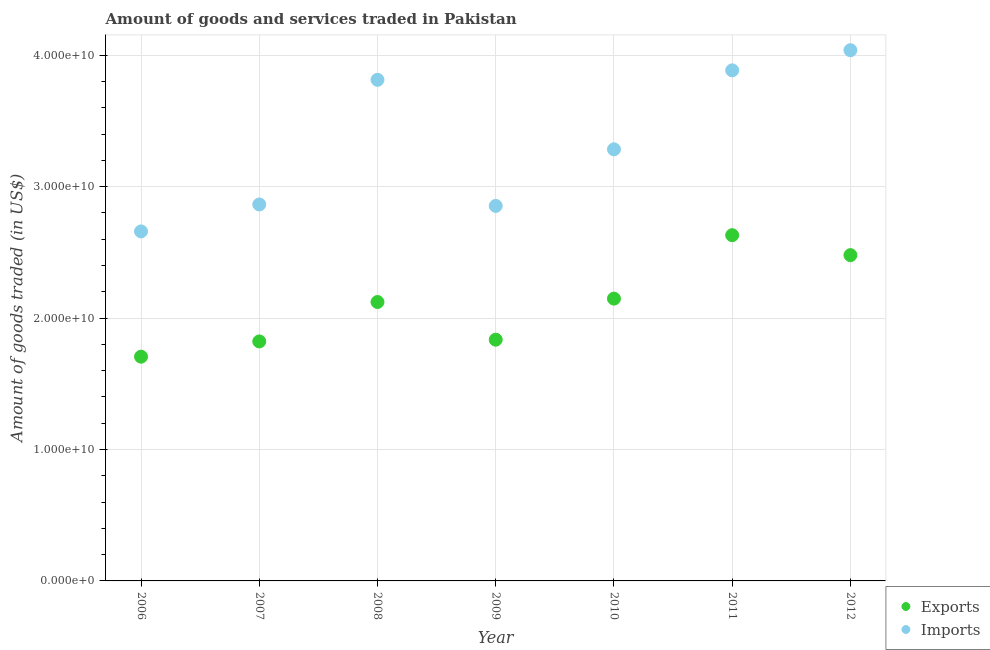How many different coloured dotlines are there?
Make the answer very short. 2. What is the amount of goods exported in 2006?
Provide a succinct answer. 1.71e+1. Across all years, what is the maximum amount of goods imported?
Provide a succinct answer. 4.04e+1. Across all years, what is the minimum amount of goods imported?
Your answer should be very brief. 2.66e+1. In which year was the amount of goods exported maximum?
Provide a short and direct response. 2011. What is the total amount of goods imported in the graph?
Your response must be concise. 2.34e+11. What is the difference between the amount of goods imported in 2006 and that in 2010?
Provide a succinct answer. -6.24e+09. What is the difference between the amount of goods exported in 2010 and the amount of goods imported in 2012?
Offer a terse response. -1.89e+1. What is the average amount of goods exported per year?
Keep it short and to the point. 2.11e+1. In the year 2006, what is the difference between the amount of goods exported and amount of goods imported?
Give a very brief answer. -9.53e+09. In how many years, is the amount of goods exported greater than 6000000000 US$?
Provide a short and direct response. 7. What is the ratio of the amount of goods exported in 2007 to that in 2010?
Provide a succinct answer. 0.85. Is the amount of goods imported in 2010 less than that in 2012?
Provide a short and direct response. Yes. What is the difference between the highest and the second highest amount of goods exported?
Offer a very short reply. 1.52e+09. What is the difference between the highest and the lowest amount of goods imported?
Give a very brief answer. 1.38e+1. Is the sum of the amount of goods imported in 2007 and 2009 greater than the maximum amount of goods exported across all years?
Offer a terse response. Yes. Does the amount of goods exported monotonically increase over the years?
Provide a succinct answer. No. What is the difference between two consecutive major ticks on the Y-axis?
Ensure brevity in your answer.  1.00e+1. Does the graph contain any zero values?
Offer a terse response. No. Does the graph contain grids?
Provide a short and direct response. Yes. Where does the legend appear in the graph?
Offer a very short reply. Bottom right. How are the legend labels stacked?
Give a very brief answer. Vertical. What is the title of the graph?
Keep it short and to the point. Amount of goods and services traded in Pakistan. What is the label or title of the Y-axis?
Your answer should be compact. Amount of goods traded (in US$). What is the Amount of goods traded (in US$) of Exports in 2006?
Your response must be concise. 1.71e+1. What is the Amount of goods traded (in US$) in Imports in 2006?
Provide a short and direct response. 2.66e+1. What is the Amount of goods traded (in US$) of Exports in 2007?
Keep it short and to the point. 1.82e+1. What is the Amount of goods traded (in US$) in Imports in 2007?
Offer a very short reply. 2.86e+1. What is the Amount of goods traded (in US$) of Exports in 2008?
Provide a short and direct response. 2.12e+1. What is the Amount of goods traded (in US$) in Imports in 2008?
Ensure brevity in your answer.  3.81e+1. What is the Amount of goods traded (in US$) in Exports in 2009?
Provide a succinct answer. 1.84e+1. What is the Amount of goods traded (in US$) of Imports in 2009?
Your response must be concise. 2.85e+1. What is the Amount of goods traded (in US$) of Exports in 2010?
Your answer should be very brief. 2.15e+1. What is the Amount of goods traded (in US$) of Imports in 2010?
Your answer should be very brief. 3.28e+1. What is the Amount of goods traded (in US$) in Exports in 2011?
Your answer should be compact. 2.63e+1. What is the Amount of goods traded (in US$) of Imports in 2011?
Your answer should be very brief. 3.89e+1. What is the Amount of goods traded (in US$) in Exports in 2012?
Offer a terse response. 2.48e+1. What is the Amount of goods traded (in US$) in Imports in 2012?
Give a very brief answer. 4.04e+1. Across all years, what is the maximum Amount of goods traded (in US$) of Exports?
Your answer should be compact. 2.63e+1. Across all years, what is the maximum Amount of goods traded (in US$) in Imports?
Your response must be concise. 4.04e+1. Across all years, what is the minimum Amount of goods traded (in US$) of Exports?
Ensure brevity in your answer.  1.71e+1. Across all years, what is the minimum Amount of goods traded (in US$) of Imports?
Provide a short and direct response. 2.66e+1. What is the total Amount of goods traded (in US$) in Exports in the graph?
Your answer should be very brief. 1.47e+11. What is the total Amount of goods traded (in US$) in Imports in the graph?
Your response must be concise. 2.34e+11. What is the difference between the Amount of goods traded (in US$) of Exports in 2006 and that in 2007?
Your answer should be very brief. -1.16e+09. What is the difference between the Amount of goods traded (in US$) in Imports in 2006 and that in 2007?
Provide a succinct answer. -2.05e+09. What is the difference between the Amount of goods traded (in US$) in Exports in 2006 and that in 2008?
Make the answer very short. -4.16e+09. What is the difference between the Amount of goods traded (in US$) of Imports in 2006 and that in 2008?
Your answer should be very brief. -1.15e+1. What is the difference between the Amount of goods traded (in US$) of Exports in 2006 and that in 2009?
Your answer should be very brief. -1.29e+09. What is the difference between the Amount of goods traded (in US$) of Imports in 2006 and that in 2009?
Keep it short and to the point. -1.94e+09. What is the difference between the Amount of goods traded (in US$) in Exports in 2006 and that in 2010?
Keep it short and to the point. -4.42e+09. What is the difference between the Amount of goods traded (in US$) in Imports in 2006 and that in 2010?
Your response must be concise. -6.24e+09. What is the difference between the Amount of goods traded (in US$) in Exports in 2006 and that in 2011?
Give a very brief answer. -9.24e+09. What is the difference between the Amount of goods traded (in US$) of Imports in 2006 and that in 2011?
Give a very brief answer. -1.23e+1. What is the difference between the Amount of goods traded (in US$) in Exports in 2006 and that in 2012?
Your answer should be compact. -7.73e+09. What is the difference between the Amount of goods traded (in US$) of Imports in 2006 and that in 2012?
Ensure brevity in your answer.  -1.38e+1. What is the difference between the Amount of goods traded (in US$) in Exports in 2007 and that in 2008?
Provide a short and direct response. -3.00e+09. What is the difference between the Amount of goods traded (in US$) in Imports in 2007 and that in 2008?
Ensure brevity in your answer.  -9.49e+09. What is the difference between the Amount of goods traded (in US$) in Exports in 2007 and that in 2009?
Your response must be concise. -1.33e+08. What is the difference between the Amount of goods traded (in US$) in Imports in 2007 and that in 2009?
Offer a terse response. 1.10e+08. What is the difference between the Amount of goods traded (in US$) in Exports in 2007 and that in 2010?
Your answer should be very brief. -3.26e+09. What is the difference between the Amount of goods traded (in US$) of Imports in 2007 and that in 2010?
Provide a succinct answer. -4.20e+09. What is the difference between the Amount of goods traded (in US$) of Exports in 2007 and that in 2011?
Make the answer very short. -8.08e+09. What is the difference between the Amount of goods traded (in US$) in Imports in 2007 and that in 2011?
Your answer should be very brief. -1.02e+1. What is the difference between the Amount of goods traded (in US$) of Exports in 2007 and that in 2012?
Your answer should be very brief. -6.57e+09. What is the difference between the Amount of goods traded (in US$) of Imports in 2007 and that in 2012?
Your answer should be compact. -1.17e+1. What is the difference between the Amount of goods traded (in US$) of Exports in 2008 and that in 2009?
Offer a terse response. 2.87e+09. What is the difference between the Amount of goods traded (in US$) in Imports in 2008 and that in 2009?
Ensure brevity in your answer.  9.60e+09. What is the difference between the Amount of goods traded (in US$) of Exports in 2008 and that in 2010?
Ensure brevity in your answer.  -2.58e+08. What is the difference between the Amount of goods traded (in US$) in Imports in 2008 and that in 2010?
Your answer should be very brief. 5.29e+09. What is the difference between the Amount of goods traded (in US$) of Exports in 2008 and that in 2011?
Keep it short and to the point. -5.08e+09. What is the difference between the Amount of goods traded (in US$) of Imports in 2008 and that in 2011?
Your response must be concise. -7.20e+08. What is the difference between the Amount of goods traded (in US$) of Exports in 2008 and that in 2012?
Give a very brief answer. -3.57e+09. What is the difference between the Amount of goods traded (in US$) in Imports in 2008 and that in 2012?
Keep it short and to the point. -2.25e+09. What is the difference between the Amount of goods traded (in US$) of Exports in 2009 and that in 2010?
Offer a terse response. -3.12e+09. What is the difference between the Amount of goods traded (in US$) in Imports in 2009 and that in 2010?
Keep it short and to the point. -4.31e+09. What is the difference between the Amount of goods traded (in US$) of Exports in 2009 and that in 2011?
Ensure brevity in your answer.  -7.95e+09. What is the difference between the Amount of goods traded (in US$) in Imports in 2009 and that in 2011?
Offer a terse response. -1.03e+1. What is the difference between the Amount of goods traded (in US$) in Exports in 2009 and that in 2012?
Provide a short and direct response. -6.43e+09. What is the difference between the Amount of goods traded (in US$) in Imports in 2009 and that in 2012?
Keep it short and to the point. -1.18e+1. What is the difference between the Amount of goods traded (in US$) in Exports in 2010 and that in 2011?
Provide a short and direct response. -4.83e+09. What is the difference between the Amount of goods traded (in US$) of Imports in 2010 and that in 2011?
Ensure brevity in your answer.  -6.01e+09. What is the difference between the Amount of goods traded (in US$) of Exports in 2010 and that in 2012?
Your answer should be compact. -3.31e+09. What is the difference between the Amount of goods traded (in US$) of Imports in 2010 and that in 2012?
Your answer should be compact. -7.54e+09. What is the difference between the Amount of goods traded (in US$) in Exports in 2011 and that in 2012?
Provide a short and direct response. 1.52e+09. What is the difference between the Amount of goods traded (in US$) of Imports in 2011 and that in 2012?
Ensure brevity in your answer.  -1.53e+09. What is the difference between the Amount of goods traded (in US$) of Exports in 2006 and the Amount of goods traded (in US$) of Imports in 2007?
Provide a short and direct response. -1.16e+1. What is the difference between the Amount of goods traded (in US$) of Exports in 2006 and the Amount of goods traded (in US$) of Imports in 2008?
Ensure brevity in your answer.  -2.11e+1. What is the difference between the Amount of goods traded (in US$) in Exports in 2006 and the Amount of goods traded (in US$) in Imports in 2009?
Make the answer very short. -1.15e+1. What is the difference between the Amount of goods traded (in US$) in Exports in 2006 and the Amount of goods traded (in US$) in Imports in 2010?
Offer a very short reply. -1.58e+1. What is the difference between the Amount of goods traded (in US$) in Exports in 2006 and the Amount of goods traded (in US$) in Imports in 2011?
Your response must be concise. -2.18e+1. What is the difference between the Amount of goods traded (in US$) of Exports in 2006 and the Amount of goods traded (in US$) of Imports in 2012?
Your response must be concise. -2.33e+1. What is the difference between the Amount of goods traded (in US$) in Exports in 2007 and the Amount of goods traded (in US$) in Imports in 2008?
Offer a very short reply. -1.99e+1. What is the difference between the Amount of goods traded (in US$) of Exports in 2007 and the Amount of goods traded (in US$) of Imports in 2009?
Provide a succinct answer. -1.03e+1. What is the difference between the Amount of goods traded (in US$) in Exports in 2007 and the Amount of goods traded (in US$) in Imports in 2010?
Offer a very short reply. -1.46e+1. What is the difference between the Amount of goods traded (in US$) in Exports in 2007 and the Amount of goods traded (in US$) in Imports in 2011?
Make the answer very short. -2.06e+1. What is the difference between the Amount of goods traded (in US$) in Exports in 2007 and the Amount of goods traded (in US$) in Imports in 2012?
Your answer should be very brief. -2.22e+1. What is the difference between the Amount of goods traded (in US$) in Exports in 2008 and the Amount of goods traded (in US$) in Imports in 2009?
Offer a very short reply. -7.31e+09. What is the difference between the Amount of goods traded (in US$) in Exports in 2008 and the Amount of goods traded (in US$) in Imports in 2010?
Ensure brevity in your answer.  -1.16e+1. What is the difference between the Amount of goods traded (in US$) in Exports in 2008 and the Amount of goods traded (in US$) in Imports in 2011?
Give a very brief answer. -1.76e+1. What is the difference between the Amount of goods traded (in US$) in Exports in 2008 and the Amount of goods traded (in US$) in Imports in 2012?
Provide a short and direct response. -1.92e+1. What is the difference between the Amount of goods traded (in US$) of Exports in 2009 and the Amount of goods traded (in US$) of Imports in 2010?
Keep it short and to the point. -1.45e+1. What is the difference between the Amount of goods traded (in US$) in Exports in 2009 and the Amount of goods traded (in US$) in Imports in 2011?
Make the answer very short. -2.05e+1. What is the difference between the Amount of goods traded (in US$) of Exports in 2009 and the Amount of goods traded (in US$) of Imports in 2012?
Your response must be concise. -2.20e+1. What is the difference between the Amount of goods traded (in US$) of Exports in 2010 and the Amount of goods traded (in US$) of Imports in 2011?
Provide a short and direct response. -1.74e+1. What is the difference between the Amount of goods traded (in US$) of Exports in 2010 and the Amount of goods traded (in US$) of Imports in 2012?
Offer a very short reply. -1.89e+1. What is the difference between the Amount of goods traded (in US$) in Exports in 2011 and the Amount of goods traded (in US$) in Imports in 2012?
Keep it short and to the point. -1.41e+1. What is the average Amount of goods traded (in US$) in Exports per year?
Offer a very short reply. 2.11e+1. What is the average Amount of goods traded (in US$) in Imports per year?
Your response must be concise. 3.34e+1. In the year 2006, what is the difference between the Amount of goods traded (in US$) in Exports and Amount of goods traded (in US$) in Imports?
Provide a short and direct response. -9.53e+09. In the year 2007, what is the difference between the Amount of goods traded (in US$) in Exports and Amount of goods traded (in US$) in Imports?
Offer a terse response. -1.04e+1. In the year 2008, what is the difference between the Amount of goods traded (in US$) in Exports and Amount of goods traded (in US$) in Imports?
Provide a succinct answer. -1.69e+1. In the year 2009, what is the difference between the Amount of goods traded (in US$) in Exports and Amount of goods traded (in US$) in Imports?
Your response must be concise. -1.02e+1. In the year 2010, what is the difference between the Amount of goods traded (in US$) in Exports and Amount of goods traded (in US$) in Imports?
Give a very brief answer. -1.14e+1. In the year 2011, what is the difference between the Amount of goods traded (in US$) in Exports and Amount of goods traded (in US$) in Imports?
Make the answer very short. -1.25e+1. In the year 2012, what is the difference between the Amount of goods traded (in US$) in Exports and Amount of goods traded (in US$) in Imports?
Provide a short and direct response. -1.56e+1. What is the ratio of the Amount of goods traded (in US$) of Exports in 2006 to that in 2007?
Keep it short and to the point. 0.94. What is the ratio of the Amount of goods traded (in US$) of Imports in 2006 to that in 2007?
Offer a terse response. 0.93. What is the ratio of the Amount of goods traded (in US$) in Exports in 2006 to that in 2008?
Keep it short and to the point. 0.8. What is the ratio of the Amount of goods traded (in US$) of Imports in 2006 to that in 2008?
Your response must be concise. 0.7. What is the ratio of the Amount of goods traded (in US$) in Exports in 2006 to that in 2009?
Provide a succinct answer. 0.93. What is the ratio of the Amount of goods traded (in US$) of Imports in 2006 to that in 2009?
Your answer should be compact. 0.93. What is the ratio of the Amount of goods traded (in US$) of Exports in 2006 to that in 2010?
Give a very brief answer. 0.79. What is the ratio of the Amount of goods traded (in US$) of Imports in 2006 to that in 2010?
Provide a succinct answer. 0.81. What is the ratio of the Amount of goods traded (in US$) in Exports in 2006 to that in 2011?
Ensure brevity in your answer.  0.65. What is the ratio of the Amount of goods traded (in US$) of Imports in 2006 to that in 2011?
Offer a terse response. 0.68. What is the ratio of the Amount of goods traded (in US$) of Exports in 2006 to that in 2012?
Your answer should be compact. 0.69. What is the ratio of the Amount of goods traded (in US$) of Imports in 2006 to that in 2012?
Your answer should be very brief. 0.66. What is the ratio of the Amount of goods traded (in US$) of Exports in 2007 to that in 2008?
Your response must be concise. 0.86. What is the ratio of the Amount of goods traded (in US$) in Imports in 2007 to that in 2008?
Ensure brevity in your answer.  0.75. What is the ratio of the Amount of goods traded (in US$) in Exports in 2007 to that in 2009?
Offer a terse response. 0.99. What is the ratio of the Amount of goods traded (in US$) of Imports in 2007 to that in 2009?
Give a very brief answer. 1. What is the ratio of the Amount of goods traded (in US$) of Exports in 2007 to that in 2010?
Keep it short and to the point. 0.85. What is the ratio of the Amount of goods traded (in US$) in Imports in 2007 to that in 2010?
Offer a terse response. 0.87. What is the ratio of the Amount of goods traded (in US$) in Exports in 2007 to that in 2011?
Offer a terse response. 0.69. What is the ratio of the Amount of goods traded (in US$) of Imports in 2007 to that in 2011?
Offer a terse response. 0.74. What is the ratio of the Amount of goods traded (in US$) of Exports in 2007 to that in 2012?
Keep it short and to the point. 0.74. What is the ratio of the Amount of goods traded (in US$) in Imports in 2007 to that in 2012?
Provide a short and direct response. 0.71. What is the ratio of the Amount of goods traded (in US$) of Exports in 2008 to that in 2009?
Give a very brief answer. 1.16. What is the ratio of the Amount of goods traded (in US$) of Imports in 2008 to that in 2009?
Your answer should be compact. 1.34. What is the ratio of the Amount of goods traded (in US$) of Exports in 2008 to that in 2010?
Offer a very short reply. 0.99. What is the ratio of the Amount of goods traded (in US$) of Imports in 2008 to that in 2010?
Ensure brevity in your answer.  1.16. What is the ratio of the Amount of goods traded (in US$) of Exports in 2008 to that in 2011?
Provide a succinct answer. 0.81. What is the ratio of the Amount of goods traded (in US$) of Imports in 2008 to that in 2011?
Your answer should be compact. 0.98. What is the ratio of the Amount of goods traded (in US$) in Exports in 2008 to that in 2012?
Provide a succinct answer. 0.86. What is the ratio of the Amount of goods traded (in US$) in Imports in 2008 to that in 2012?
Offer a terse response. 0.94. What is the ratio of the Amount of goods traded (in US$) of Exports in 2009 to that in 2010?
Provide a succinct answer. 0.85. What is the ratio of the Amount of goods traded (in US$) of Imports in 2009 to that in 2010?
Your answer should be compact. 0.87. What is the ratio of the Amount of goods traded (in US$) of Exports in 2009 to that in 2011?
Your answer should be compact. 0.7. What is the ratio of the Amount of goods traded (in US$) in Imports in 2009 to that in 2011?
Keep it short and to the point. 0.73. What is the ratio of the Amount of goods traded (in US$) in Exports in 2009 to that in 2012?
Keep it short and to the point. 0.74. What is the ratio of the Amount of goods traded (in US$) in Imports in 2009 to that in 2012?
Your answer should be very brief. 0.71. What is the ratio of the Amount of goods traded (in US$) in Exports in 2010 to that in 2011?
Offer a terse response. 0.82. What is the ratio of the Amount of goods traded (in US$) in Imports in 2010 to that in 2011?
Offer a terse response. 0.85. What is the ratio of the Amount of goods traded (in US$) of Exports in 2010 to that in 2012?
Offer a very short reply. 0.87. What is the ratio of the Amount of goods traded (in US$) in Imports in 2010 to that in 2012?
Your answer should be very brief. 0.81. What is the ratio of the Amount of goods traded (in US$) in Exports in 2011 to that in 2012?
Your response must be concise. 1.06. What is the ratio of the Amount of goods traded (in US$) in Imports in 2011 to that in 2012?
Give a very brief answer. 0.96. What is the difference between the highest and the second highest Amount of goods traded (in US$) in Exports?
Give a very brief answer. 1.52e+09. What is the difference between the highest and the second highest Amount of goods traded (in US$) of Imports?
Provide a short and direct response. 1.53e+09. What is the difference between the highest and the lowest Amount of goods traded (in US$) of Exports?
Your answer should be very brief. 9.24e+09. What is the difference between the highest and the lowest Amount of goods traded (in US$) of Imports?
Your answer should be very brief. 1.38e+1. 